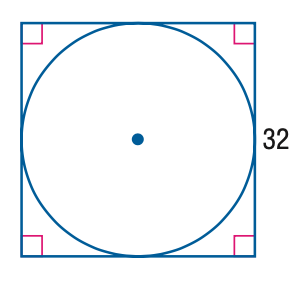Answer the mathemtical geometry problem and directly provide the correct option letter.
Question: Find the exact circumference of the circle below.
Choices: A: 16 \pi B: 32 \pi C: 128 \pi D: 256 \pi B 